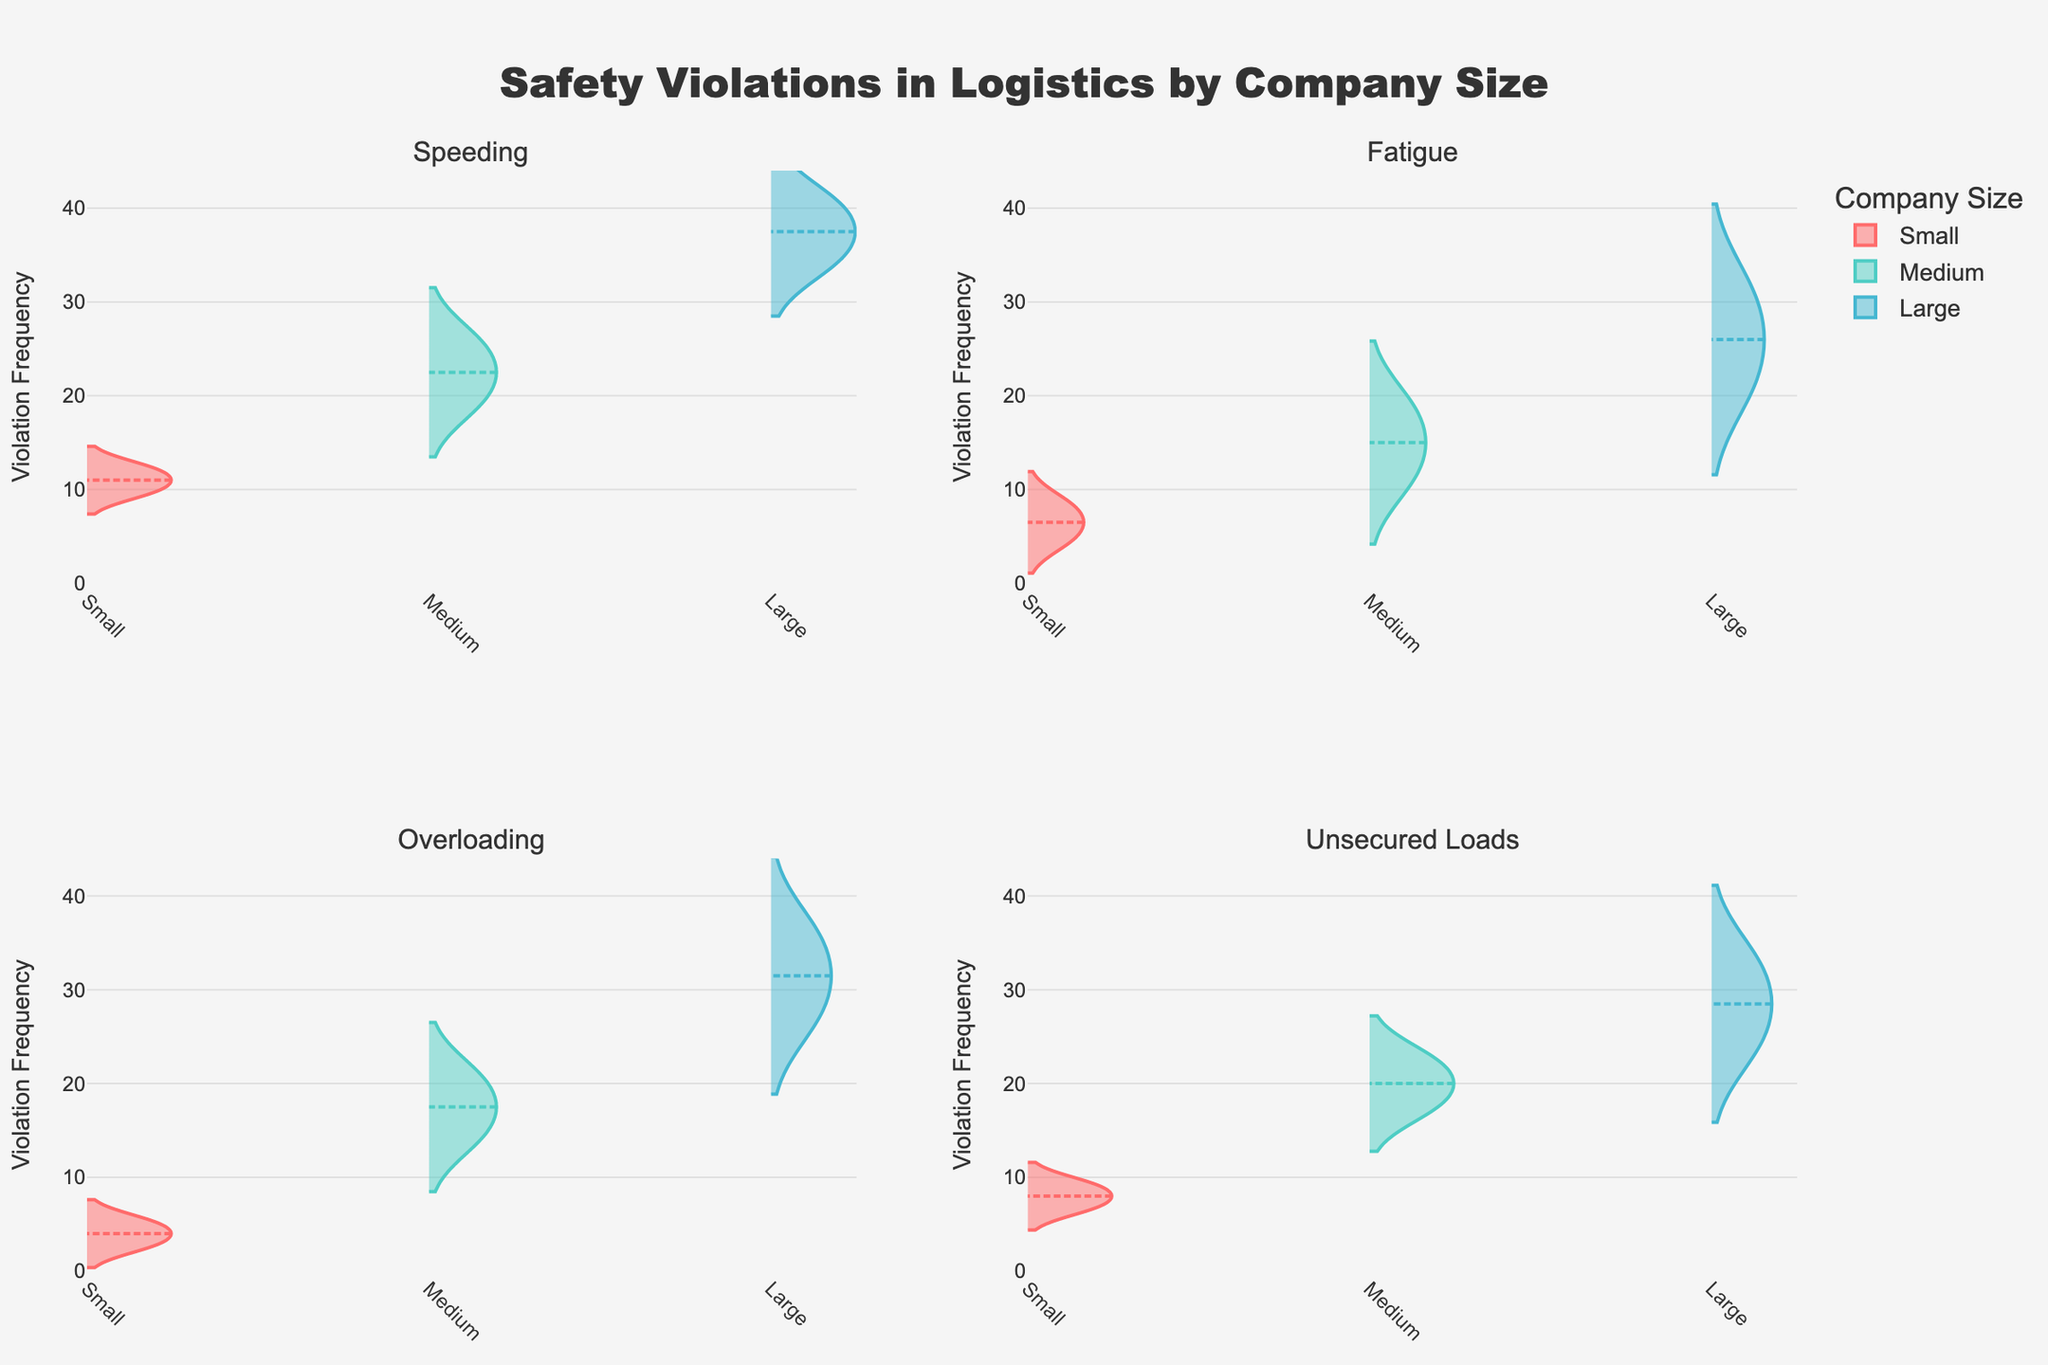What is the title of the figure? The title of the figure is shown at the top of the plot. It reads: "Safety Violations in Logistics by Company Size."
Answer: Safety Violations in Logistics by Company Size Which company size has the highest median value for Speeding violations? The median value is indicated by the dashed line in the violin plot for Speeding. By comparing the lines, the company size 'Large' has the highest median.
Answer: Large How many subplots are there in the figure? There are a total of 4 subplots, as each Violation Type has its own subplot visible in a 2x2 grid.
Answer: 4 In the subplot for Overloading violations, which company size shows the highest range of violation frequencies? In the violin plot of Overloading violations, the range is represented by the width of the violin. The company size 'Large' has the widest range.
Answer: Large What is the maximum Violation Frequency observed across all plots? The y-axes of all subplots are standardized. The highest point observed in all plots is slightly above 40, so the maximum value is 40.
Answer: 40 Which Violation Type has the least variation in violation frequencies across all company sizes? Variation can be seen by the width and spread of the violins. For Unsecured Loads, the violins across all company sizes are relatively narrow and less spread out, indicating the least variation.
Answer: Unsecured Loads Which company size has the lowest median value for Fatigue violations? The median value is indicated by the dashed line in the violin plot for Fatigue. The company size 'Small' has the lowest median value.
Answer: Small Compare the mean line values of Speeding violations for Small and Large company sizes. Which one is higher? Mean lines are visible as solid lines inside the violins. For Speeding, the solid line in the Large company's violin is higher than in the Small company's.
Answer: Large What is the leyend title text of the plot? The legend title is positioned next to the categories in the plot. It reads: "Company Size."
Answer: Company Size 